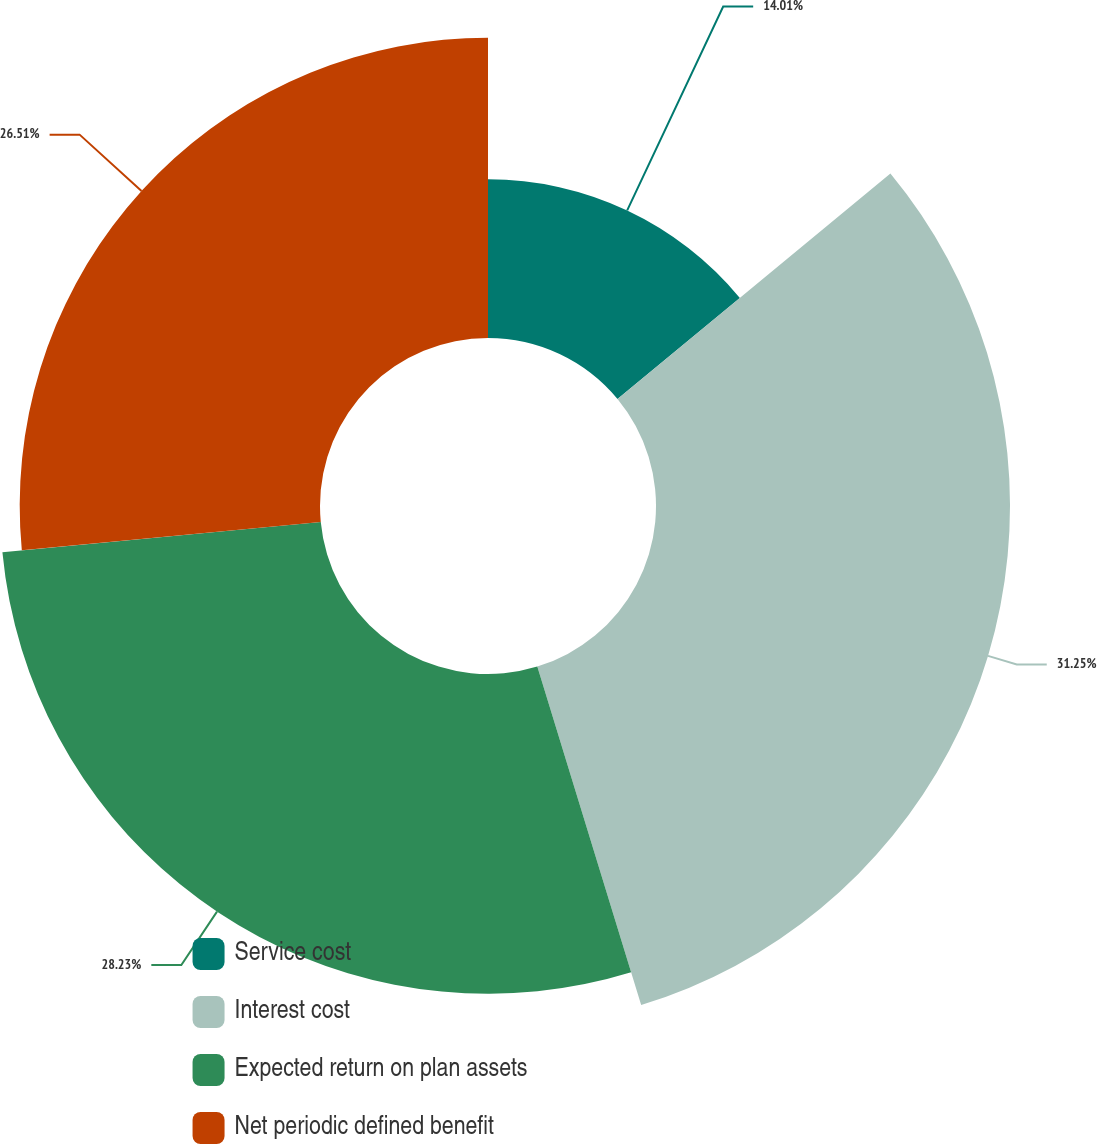Convert chart. <chart><loc_0><loc_0><loc_500><loc_500><pie_chart><fcel>Service cost<fcel>Interest cost<fcel>Expected return on plan assets<fcel>Net periodic defined benefit<nl><fcel>14.01%<fcel>31.25%<fcel>28.23%<fcel>26.51%<nl></chart> 